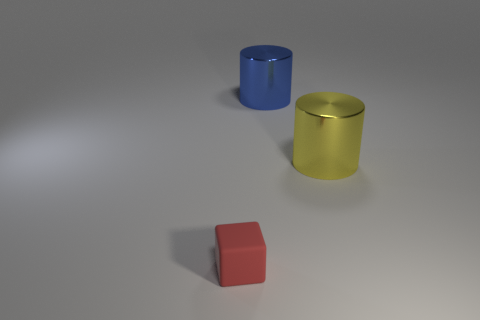Add 2 cylinders. How many objects exist? 5 Subtract all brown cubes. How many gray cylinders are left? 0 Subtract all blue cylinders. How many cylinders are left? 1 Subtract 1 cylinders. How many cylinders are left? 1 Subtract all big green rubber objects. Subtract all yellow cylinders. How many objects are left? 2 Add 1 shiny cylinders. How many shiny cylinders are left? 3 Add 2 big brown cubes. How many big brown cubes exist? 2 Subtract 0 gray cubes. How many objects are left? 3 Subtract all cubes. How many objects are left? 2 Subtract all gray cylinders. Subtract all purple spheres. How many cylinders are left? 2 